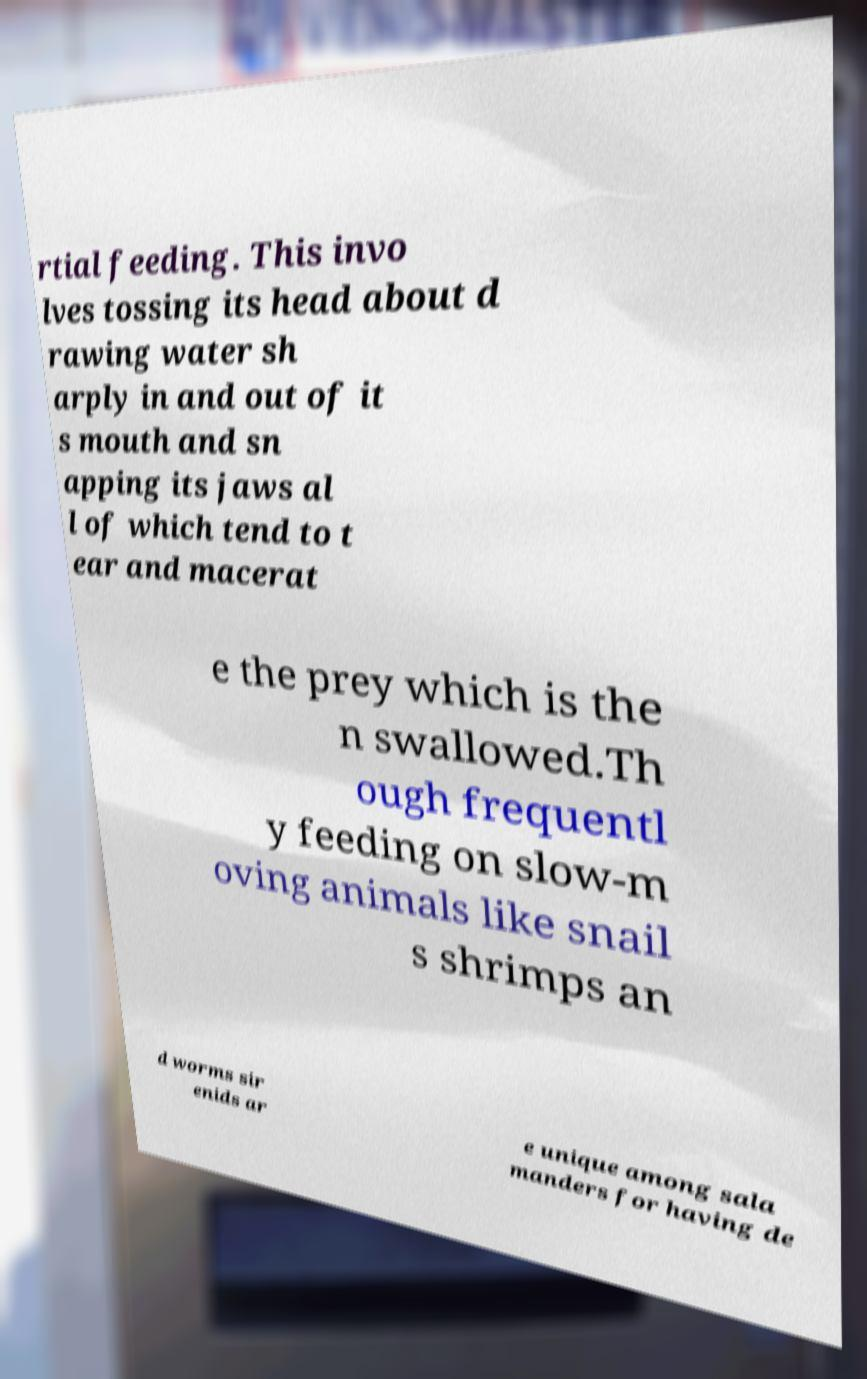Please identify and transcribe the text found in this image. rtial feeding. This invo lves tossing its head about d rawing water sh arply in and out of it s mouth and sn apping its jaws al l of which tend to t ear and macerat e the prey which is the n swallowed.Th ough frequentl y feeding on slow-m oving animals like snail s shrimps an d worms sir enids ar e unique among sala manders for having de 